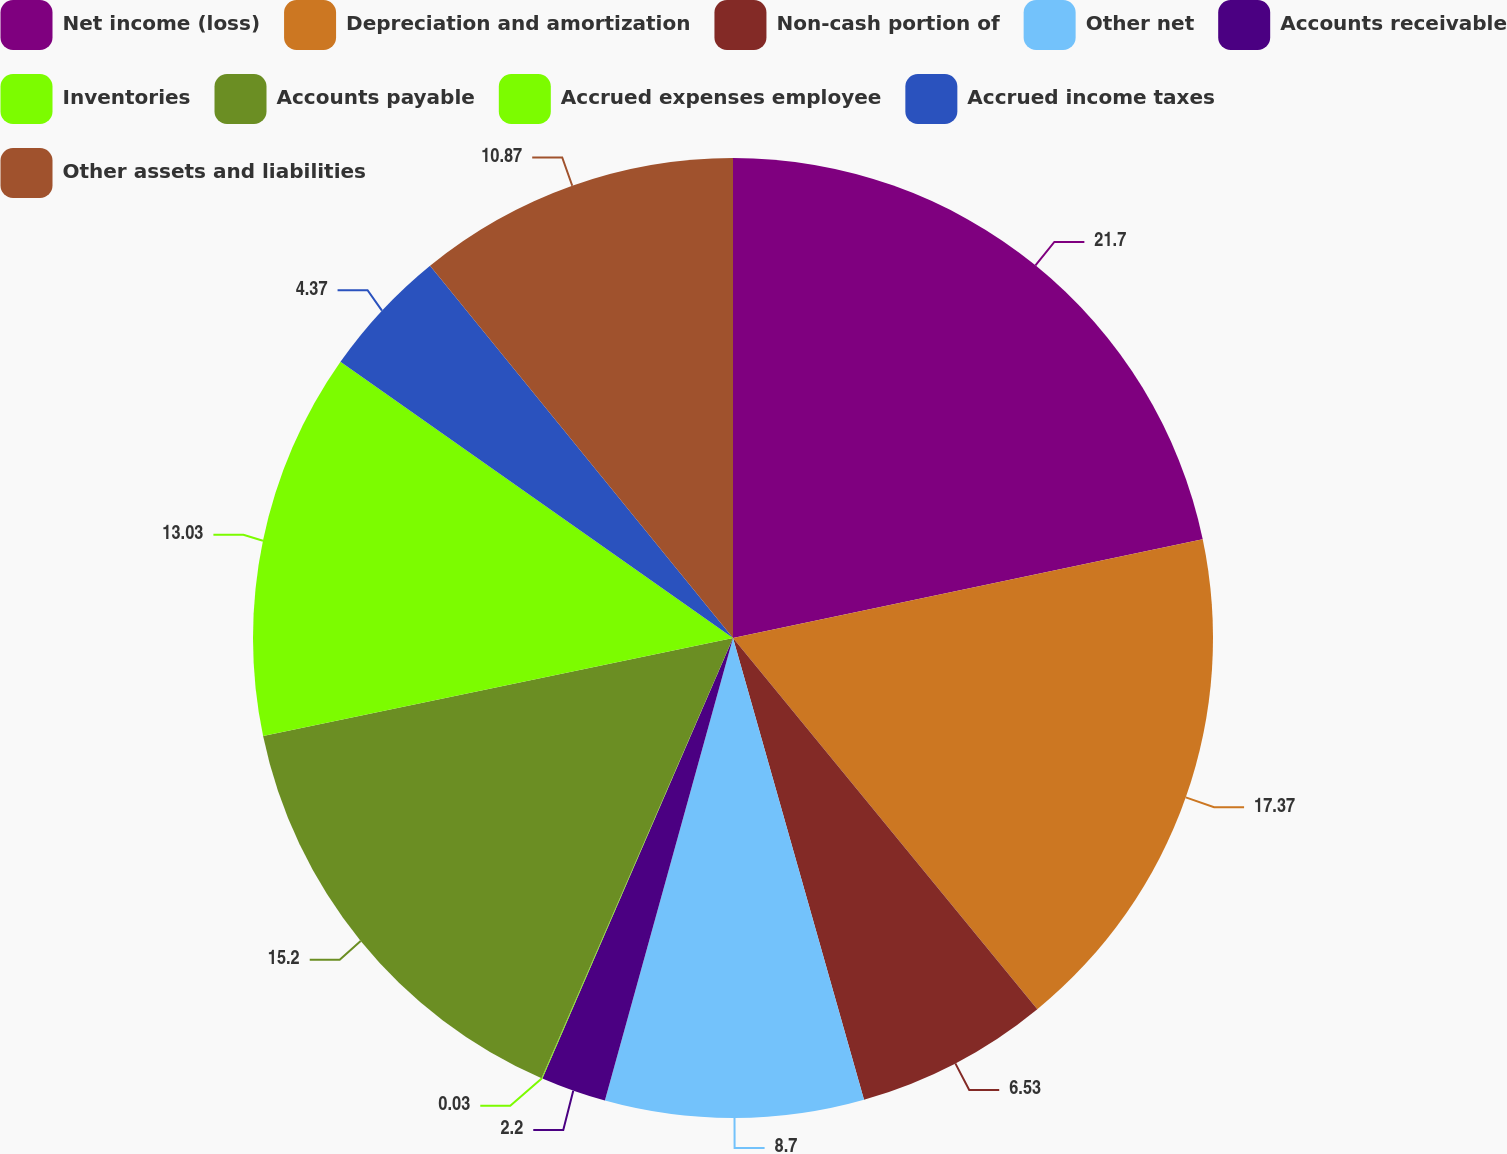Convert chart to OTSL. <chart><loc_0><loc_0><loc_500><loc_500><pie_chart><fcel>Net income (loss)<fcel>Depreciation and amortization<fcel>Non-cash portion of<fcel>Other net<fcel>Accounts receivable<fcel>Inventories<fcel>Accounts payable<fcel>Accrued expenses employee<fcel>Accrued income taxes<fcel>Other assets and liabilities<nl><fcel>21.7%<fcel>17.37%<fcel>6.53%<fcel>8.7%<fcel>2.2%<fcel>0.03%<fcel>15.2%<fcel>13.03%<fcel>4.37%<fcel>10.87%<nl></chart> 